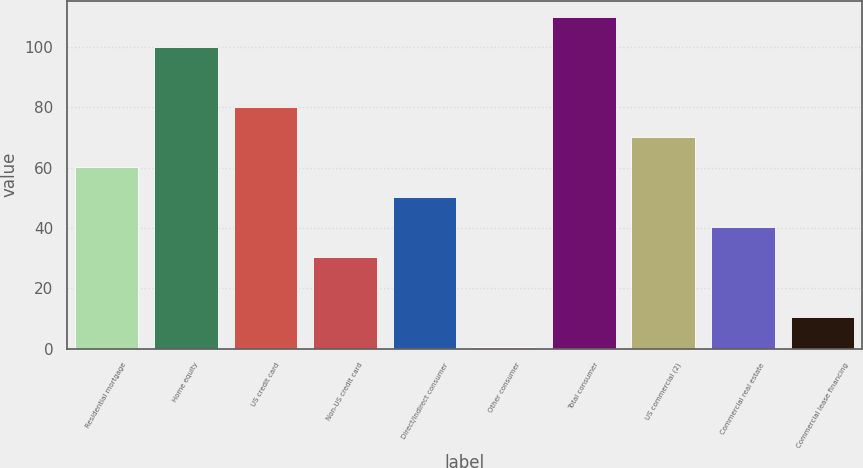Convert chart to OTSL. <chart><loc_0><loc_0><loc_500><loc_500><bar_chart><fcel>Residential mortgage<fcel>Home equity<fcel>US credit card<fcel>Non-US credit card<fcel>Direct/Indirect consumer<fcel>Other consumer<fcel>Total consumer<fcel>US commercial (2)<fcel>Commercial real estate<fcel>Commercial lease financing<nl><fcel>60.23<fcel>100<fcel>80.12<fcel>30.39<fcel>50.29<fcel>0.55<fcel>109.94<fcel>70.17<fcel>40.34<fcel>10.5<nl></chart> 